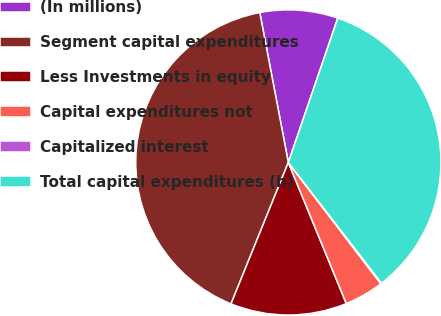Convert chart to OTSL. <chart><loc_0><loc_0><loc_500><loc_500><pie_chart><fcel>(In millions)<fcel>Segment capital expenditures<fcel>Less Investments in equity<fcel>Capital expenditures not<fcel>Capitalized interest<fcel>Total capital expenditures (b)<nl><fcel>8.25%<fcel>40.87%<fcel>12.33%<fcel>4.17%<fcel>0.09%<fcel>34.28%<nl></chart> 